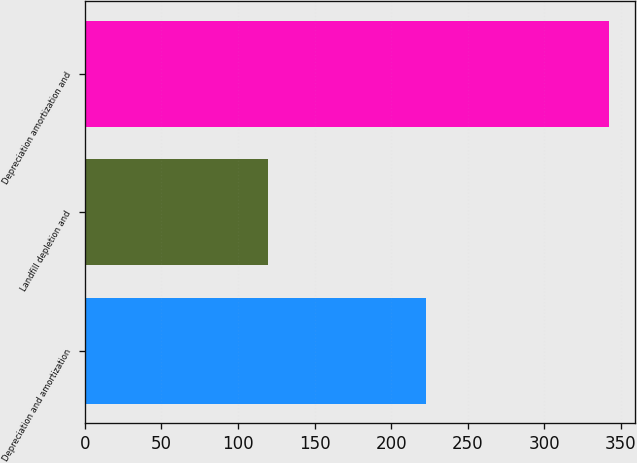Convert chart. <chart><loc_0><loc_0><loc_500><loc_500><bar_chart><fcel>Depreciation and amortization<fcel>Landfill depletion and<fcel>Depreciation amortization and<nl><fcel>222.6<fcel>119.7<fcel>342.3<nl></chart> 